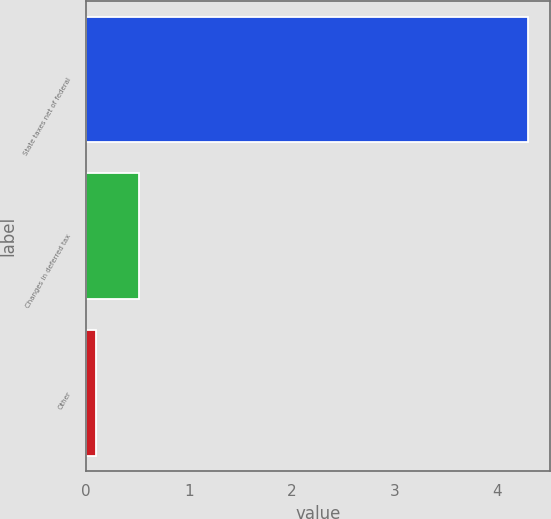Convert chart. <chart><loc_0><loc_0><loc_500><loc_500><bar_chart><fcel>State taxes net of federal<fcel>Changes in deferred tax<fcel>Other<nl><fcel>4.3<fcel>0.52<fcel>0.1<nl></chart> 